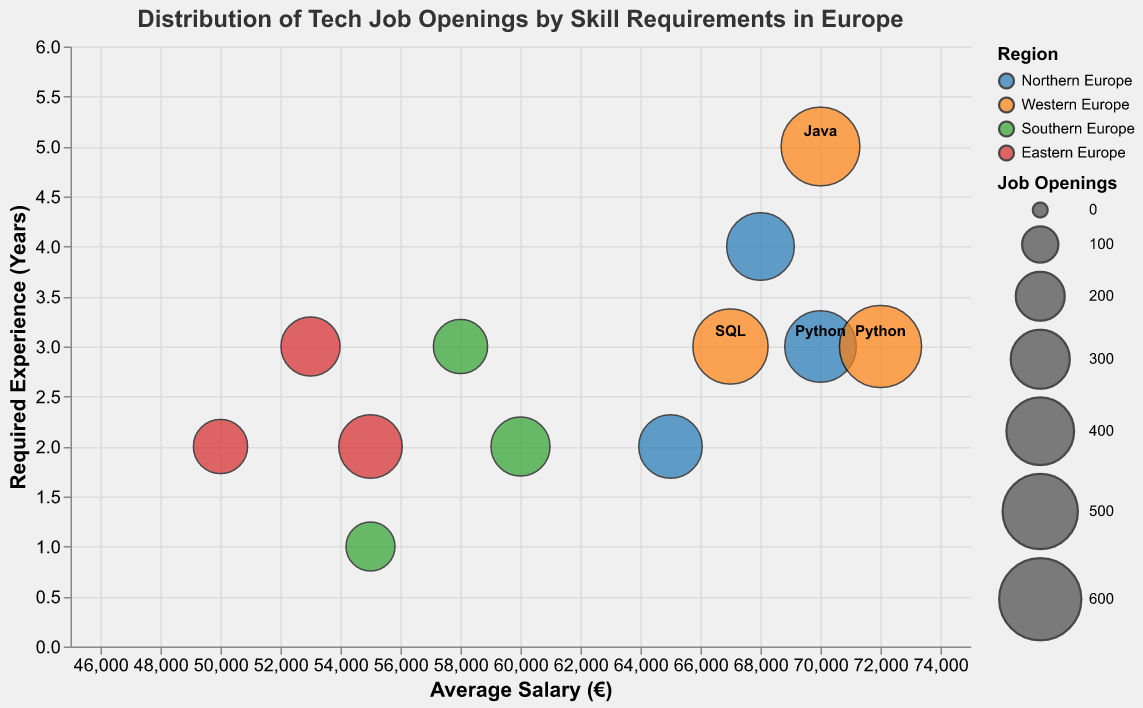What is the title of the figure? The title of the figure is displayed prominently at the top. The title text is "Distribution of Tech Job Openings by Skill Requirements in Europe".
Answer: Distribution of Tech Job Openings by Skill Requirements in Europe Which skill has the highest number of job openings in Western Europe? To determine this, look at the bubbles corresponding to Western Europe (colored in orange) and identify the skill with the largest bubble size. The largest bubble in Western Europe corresponds to Python with 600 job openings.
Answer: Python What is the average salary for SQL jobs in Northern Europe? Locate the bubble corresponding to SQL in Northern Europe (blue color). The tooltip information shows that the average salary for SQL jobs in Northern Europe is €65,000.
Answer: €65,000 Which region offers the highest average salary for Java jobs? Compare the average salaries for Java jobs across different regions. The regions are color-coded, and Java jobs in Western Europe (orange) have the highest average salary of €70,000.
Answer: Western Europe What is the required experience for Python jobs in Southern Europe? Look at the bubbles depicting Python jobs in Southern Europe (green color). According to the tooltip, the required experience for Python jobs in this region is 2 years.
Answer: 2 years Which region has the lowest average salary for SQL jobs? Assess the average salaries for SQL jobs across various regions. Eastern Europe (red) has the lowest average salary for SQL jobs at €50,000.
Answer: Eastern Europe How many job openings are there for Java in Eastern Europe? Locate the bubble representing Java jobs in Eastern Europe (red). The tooltip reveals that there are 300 job openings for Java in Eastern Europe.
Answer: 300 Compare the number of job openings for Python in Northern and Southern Europe. Which region has more? Comparing the figures, Northern Europe (blue) has 450 job openings for Python, while Southern Europe (green) has 300. Northern Europe has more job openings for Python than Southern Europe.
Answer: Northern Europe What is the relationship between required experience and average salary for tech jobs in this chart? Generally, bubbles representing data points with higher average salaries tend to align with higher required experience along the y-axis. This indicates a positive correlation between required experience and average salary for these tech jobs.
Answer: Positive correlation 